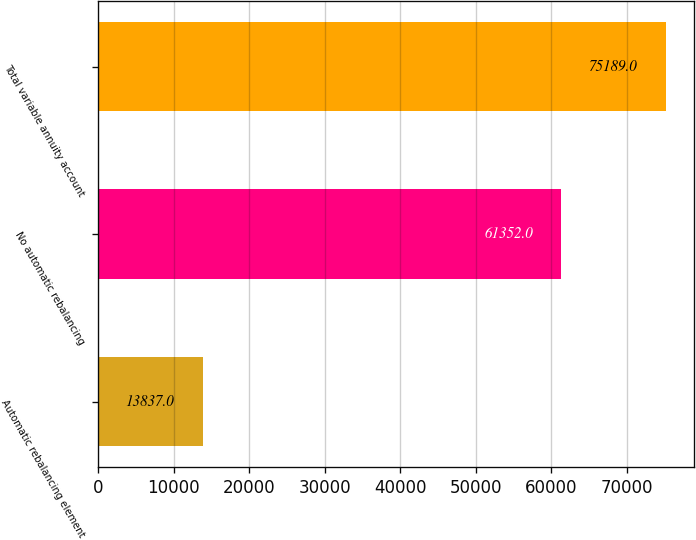<chart> <loc_0><loc_0><loc_500><loc_500><bar_chart><fcel>Automatic rebalancing element<fcel>No automatic rebalancing<fcel>Total variable annuity account<nl><fcel>13837<fcel>61352<fcel>75189<nl></chart> 